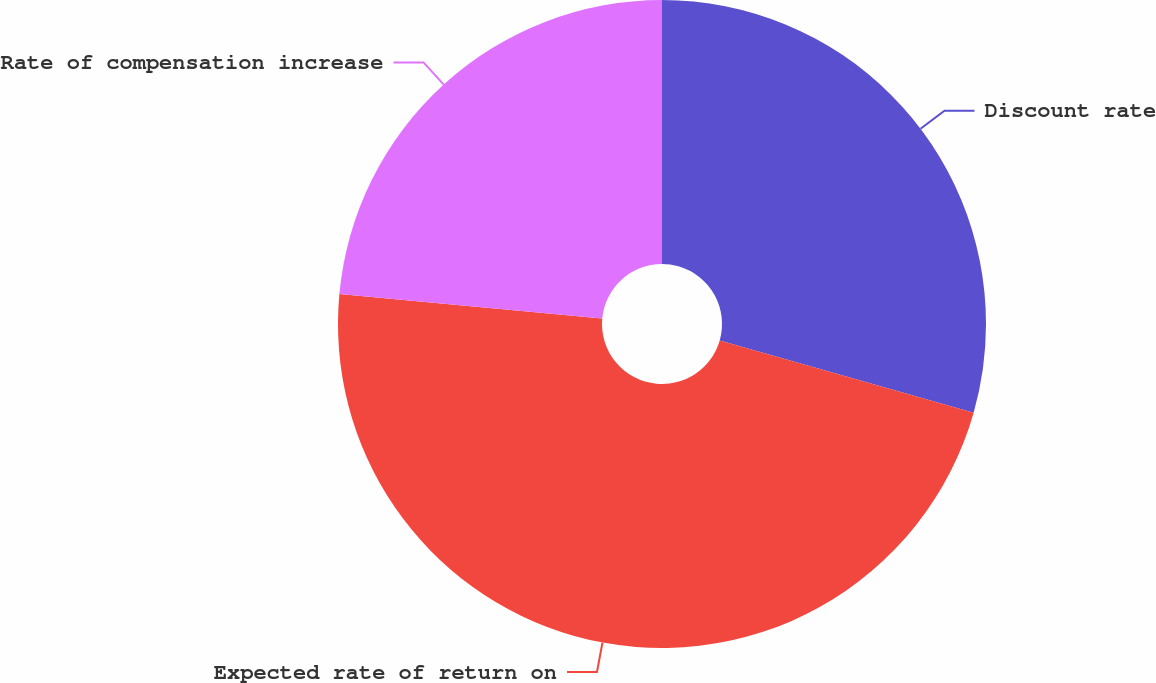Convert chart. <chart><loc_0><loc_0><loc_500><loc_500><pie_chart><fcel>Discount rate<fcel>Expected rate of return on<fcel>Rate of compensation increase<nl><fcel>29.41%<fcel>47.06%<fcel>23.53%<nl></chart> 